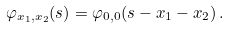Convert formula to latex. <formula><loc_0><loc_0><loc_500><loc_500>\varphi _ { x _ { 1 } , x _ { 2 } } ( s ) = \varphi _ { 0 , 0 } ( s - x _ { 1 } - x _ { 2 } ) \, .</formula> 